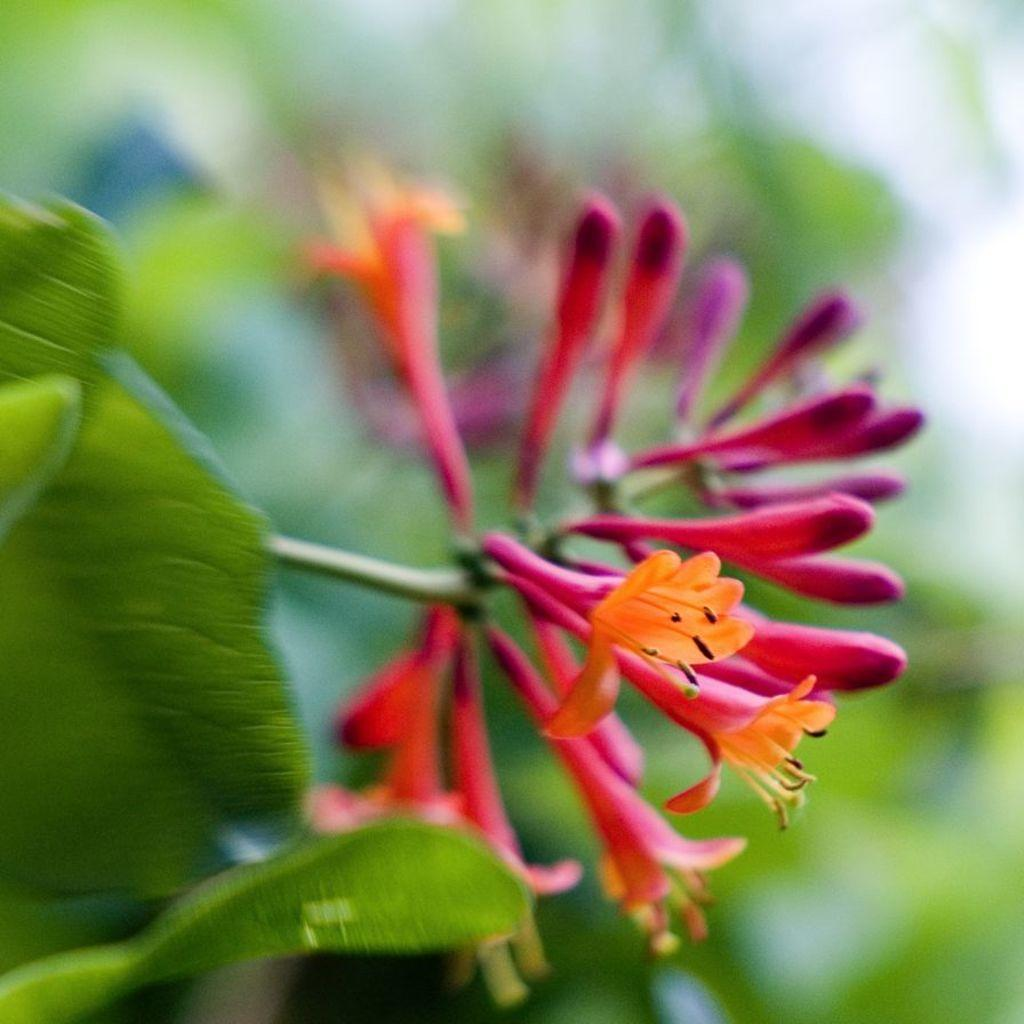What is the main subject in the center of the image? There is a flower in the center of the image. What else is present in the center of the image besides the flower? There are leaves in the center of the image. How would you describe the appearance of the background in the image? The background of the image is blurred. What type of haircut is the flower sporting in the image? The flower does not have a haircut, as it is a plant and not a person. 